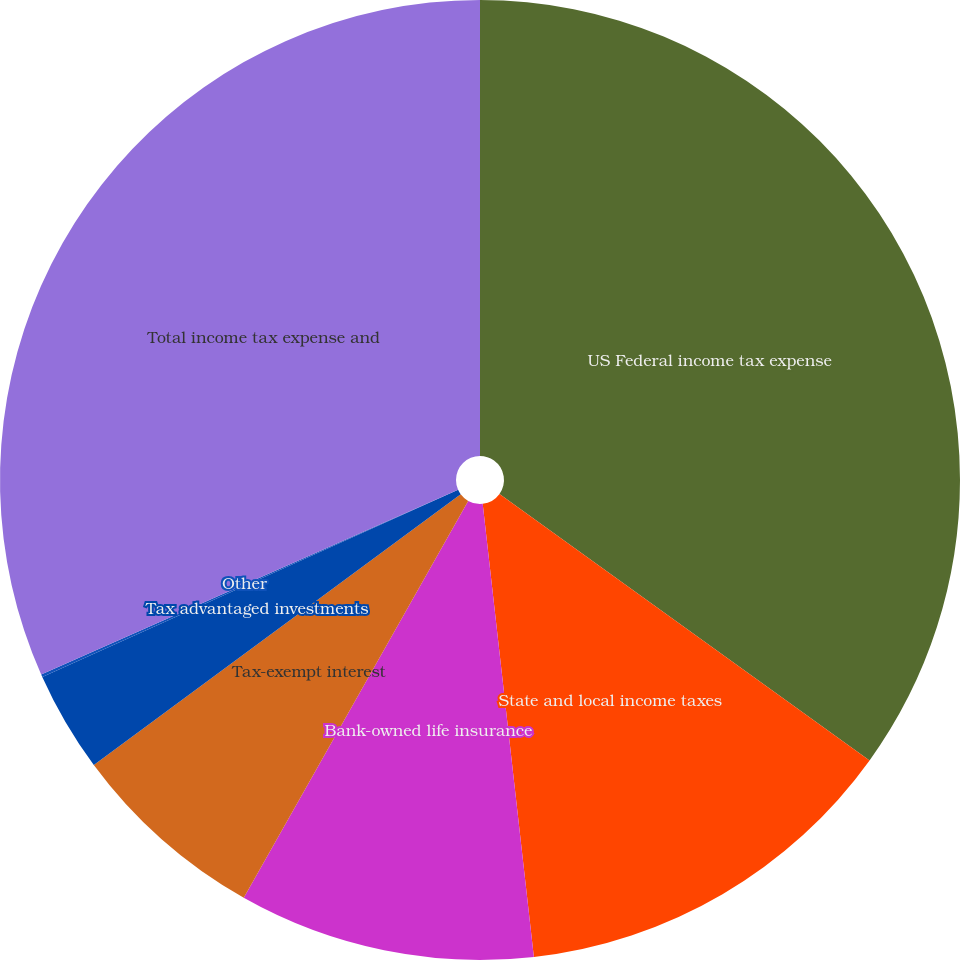Convert chart. <chart><loc_0><loc_0><loc_500><loc_500><pie_chart><fcel>US Federal income tax expense<fcel>State and local income taxes<fcel>Bank-owned life insurance<fcel>Tax-exempt interest<fcel>Tax advantaged investments<fcel>Other<fcel>Total income tax expense and<nl><fcel>34.93%<fcel>13.28%<fcel>9.98%<fcel>6.69%<fcel>3.39%<fcel>0.09%<fcel>31.64%<nl></chart> 